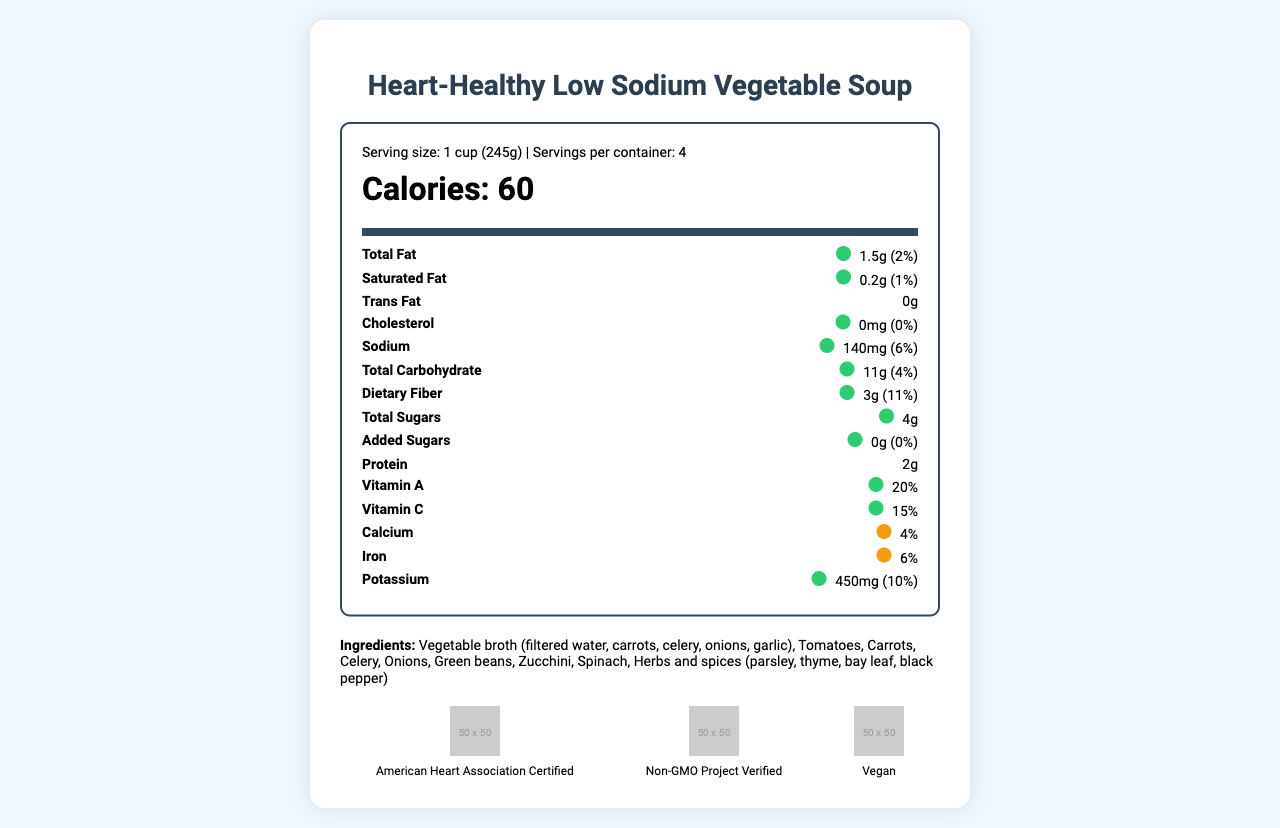What is the serving size for the Heart-Healthy Low Sodium Vegetable Soup? The serving size information is found at the top of the nutrition label with the other serving details.
Answer: 1 cup (245g) How many calories are there per serving? The calorie content is also displayed at the top of the nutrition label in a larger, bold font.
Answer: 60 calories What color is the traffic light system for sodium content in this soup? The traffic light color indication for sodium is green, denoting a low amount.
Answer: Green List the main ingredients of the soup. The ingredients are listed near the bottom of the document.
Answer: Vegetable broth (filtered water, carrots, celery, onions, garlic), Tomatoes, Carrots, Celery, Onions, Green beans, Zucchini, Spinach, Herbs and spices (parsley, thyme, bay leaf, black pepper) How many grams of dietary fiber does each serving contain? This information is stated in the section providing nutrient amounts per serving.
Answer: 3 grams Does the soup contain any common allergens? The allergen information explicitly states that the soup contains no common allergens.
Answer: No What certifications does this product have? A. American Heart Association Certified B. USDA Organic C. Non-GMO Project Verified D. Vegan The document lists "American Heart Association Certified", "Non-GMO Project Verified", and "Vegan" as the certifications.
Answer: A, C, D Which of these nutrients has the medium traffic light color, amber? A. Vitamin A B. Calcium C. Protein D. Vitamin C The traffic light color for calcium is amber, indicating a medium amount.
Answer: B Is this soup high in fiber? The document claims the soup is high in fiber, supported by the nutrient information showing 3g of dietary fiber per serving.
Answer: Yes Summarize the key information presented in the nutrition label of the Heart-Healthy Low Sodium Vegetable Soup. The summary gathers crucial details such as nutrient content, certifications, and special features about the product, reflecting its health benefits and certification attributes.
Answer: The Heart-Healthy Low Sodium Vegetable Soup offers 60 calories per serving and is low in fat, sodium, and sugars. It contains essential vitamins and minerals, high fiber content, and no added preservatives. The product is certified by the American Heart Association, Non-GMO Project Verified, and Vegan. It features a traffic light system for key nutrients, mainly showing green lights for healthier choices. How is the percent daily value for sodium expressed in this document? The percent daily value for sodium is shown as 6%, which indicates how much of the daily allowance a serving provides.
Answer: 6% What is the main feature of the traffic light system used in the nutrition facts? The traffic light system uses colors to denote the quantity of crucial nutrients—green for low, amber for medium, and red for high amounts.
Answer: To indicate the amount of key nutrients with colors What are the recommended daily values used for percent daily values based on in this document? The document does not provide information about whether the percent daily values are based on a 2000 or 2500 calorie diet.
Answer: Cannot be determined Why might someone choose this soup as part of their diet? The soup provides low sodium, essential vitamins, high fiber, and supports heart health, making it a good choice for a balanced diet and weight management.
Answer: For its low sodium content, high fiber, and rich vitamins and minerals, supporting heart health and weight management 